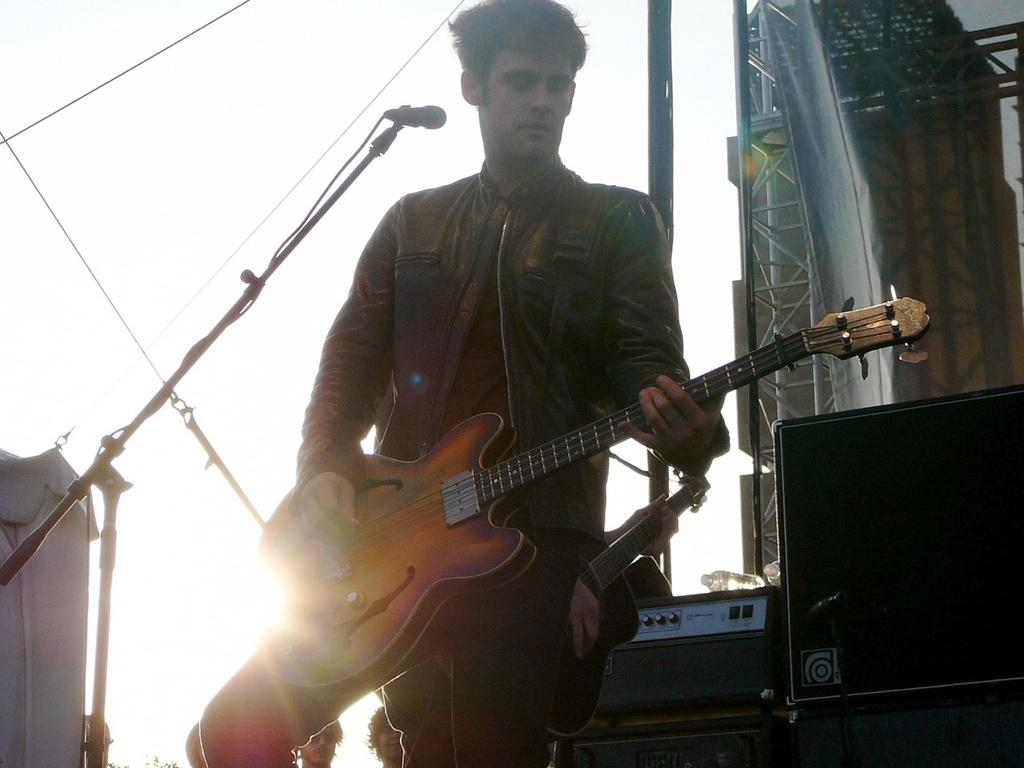What is the main subject of the image? The main subject of the image is a man. What is the man doing in the image? The man is standing and playing the guitar. Is the man crying while playing the guitar in the image? There is no indication in the image that the man is crying; he is simply playing the guitar. What type of horse can be seen in the image? There is no horse present in the image. 